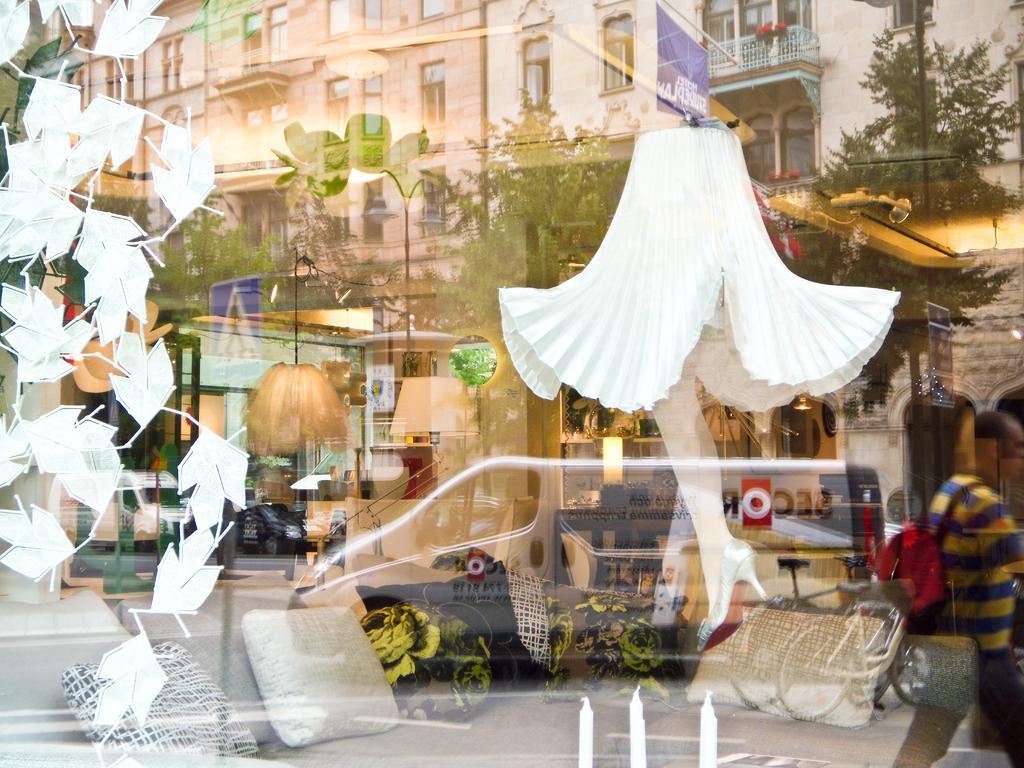How would you summarize this image in a sentence or two? In this image in the front there is a glass and on the glass there are reflections of the buildings, trees, persons, vehicles and there is an object which is white in colour and behind the glass there is a couch and on the couch there are cushions, there are candles behind the glass and there is statue. 